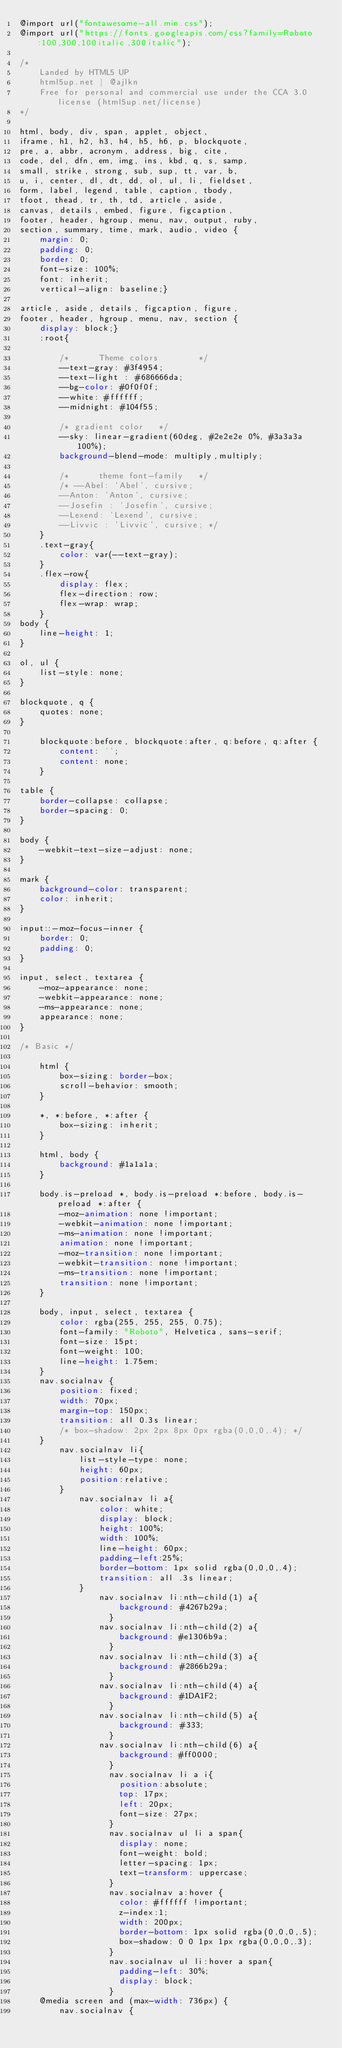<code> <loc_0><loc_0><loc_500><loc_500><_CSS_>@import url("fontawesome-all.min.css");
@import url("https://fonts.googleapis.com/css?family=Roboto:100,300,100italic,300italic");

/*
	Landed by HTML5 UP
	html5up.net | @ajlkn
	Free for personal and commercial use under the CCA 3.0 license (html5up.net/license)
*/

html, body, div, span, applet, object,
iframe, h1, h2, h3, h4, h5, h6, p, blockquote,
pre, a, abbr, acronym, address, big, cite,
code, del, dfn, em, img, ins, kbd, q, s, samp,
small, strike, strong, sub, sup, tt, var, b,
u, i, center, dl, dt, dd, ol, ul, li, fieldset,
form, label, legend, table, caption, tbody,
tfoot, thead, tr, th, td, article, aside,
canvas, details, embed, figure, figcaption,
footer, header, hgroup, menu, nav, output, ruby,
section, summary, time, mark, audio, video {
	margin: 0;
	padding: 0;
	border: 0;
	font-size: 100%;
	font: inherit;
	vertical-align: baseline;}

article, aside, details, figcaption, figure,
footer, header, hgroup, menu, nav, section {
	display: block;}
	:root{

		/*      Theme colors        */
		--text-gray: #3f4954;
		--text-light : #686666da;
		--bg-color: #0f0f0f;
		--white: #ffffff;
		--midnight: #104f55;
	
		/* gradient color   */
		--sky: linear-gradient(60deg, #2e2e2e 0%, #3a3a3a 100%);
		background-blend-mode: multiply,multiply;
	
		/*      theme font-family   */
		/* --Abel: 'Abel', cursive;
		--Anton: 'Anton', cursive;
		--Josefin : 'Josefin', cursive;
		--Lexend: 'Lexend', cursive;
		--Livvic : 'Livvic', cursive; */
	}
	.text-gray{
		color: var(--text-gray);
	}
	.flex-row{
		display: flex;
		flex-direction: row;    
		flex-wrap: wrap;
	}
body {
	line-height: 1;
}

ol, ul {
	list-style: none;
}

blockquote, q {
	quotes: none;
}

	blockquote:before, blockquote:after, q:before, q:after {
		content: '';
		content: none;
	}

table {
	border-collapse: collapse;
	border-spacing: 0;
}

body {
	-webkit-text-size-adjust: none;
}

mark {
	background-color: transparent;
	color: inherit;
}

input::-moz-focus-inner {
	border: 0;
	padding: 0;
}

input, select, textarea {
	-moz-appearance: none;
	-webkit-appearance: none;
	-ms-appearance: none;
	appearance: none;
}

/* Basic */

	html {
		box-sizing: border-box;
		scroll-behavior: smooth;
	}

	*, *:before, *:after {
		box-sizing: inherit;
	}

	html, body {
		background: #1a1a1a;
	}

	body.is-preload *, body.is-preload *:before, body.is-preload *:after {
		-moz-animation: none !important;
		-webkit-animation: none !important;
		-ms-animation: none !important;
		animation: none !important;
		-moz-transition: none !important;
		-webkit-transition: none !important;
		-ms-transition: none !important;
		transition: none !important;
	}

	body, input, select, textarea {
		color: rgba(255, 255, 255, 0.75);
		font-family: "Roboto", Helvetica, sans-serif;
		font-size: 15pt;
		font-weight: 100;
		line-height: 1.75em;
	}
	nav.socialnav {
		position: fixed;
		width: 70px;
		margin-top: 150px;
		transition: all 0.3s linear;
		/* box-shadow: 2px 2px 8px 0px rgba(0,0,0,.4); */
	}
		nav.socialnav li{
			list-style-type: none;
			height: 60px;
			position:relative;
		}
			nav.socialnav li a{
				color: white;
				display: block;
				height: 100%;
				width: 100%;
				line-height: 60px;
				padding-left:25%;
				border-bottom: 1px solid rgba(0,0,0,.4);
				transition: all .3s linear;
			}
				nav.socialnav li:nth-child(1) a{
					background: #4267b29a;
				  }
				nav.socialnav li:nth-child(2) a{
					background: #e1306b9a;
				  }
				nav.socialnav li:nth-child(3) a{
					background: #2866b29a;
				  }
				nav.socialnav li:nth-child(4) a{
					background: #1DA1F2;
				  }
				nav.socialnav li:nth-child(5) a{
					background: #333;
				  }
				nav.socialnav li:nth-child(6) a{
					background: #ff0000;
				  }
				  nav.socialnav li a i{
					position:absolute;
					top: 17px;
					left: 20px;
					font-size: 27px;
				  }	
				  nav.socialnav ul li a span{
					display: none;
					font-weight: bold;
					letter-spacing: 1px;
					text-transform: uppercase;
				  }
				  nav.socialnav a:hover {
					color: #ffffff !important;
					z-index:1;
					width: 200px;
					border-bottom: 1px solid rgba(0,0,0,.5);
					box-shadow: 0 0 1px 1px rgba(0,0,0,.3);
				  }
				  nav.socialnav ul li:hover a span{
					padding-left: 30%;
					display: block;
				  }
	@media screen and (max-width: 736px) {
		nav.socialnav {</code> 